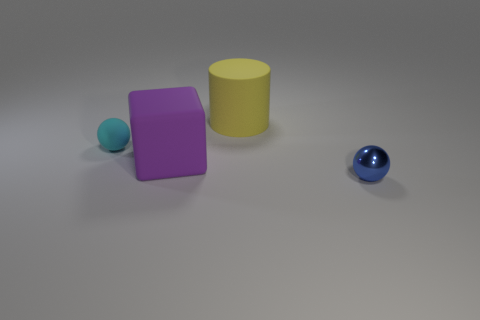Are there more objects that are behind the metallic thing than large yellow rubber cylinders that are to the right of the large rubber cylinder?
Provide a short and direct response. Yes. The tiny sphere that is on the left side of the yellow thing is what color?
Your answer should be very brief. Cyan. Is there a yellow rubber object of the same shape as the cyan thing?
Keep it short and to the point. No. What number of red objects are rubber cylinders or tiny matte balls?
Your answer should be compact. 0. Are there any other shiny cylinders of the same size as the yellow cylinder?
Your answer should be compact. No. How many brown shiny cylinders are there?
Make the answer very short. 0. What number of large objects are either blue objects or brown matte objects?
Offer a very short reply. 0. What is the color of the ball that is to the left of the ball that is in front of the small ball that is left of the blue ball?
Your answer should be very brief. Cyan. What number of other objects are the same color as the rubber sphere?
Ensure brevity in your answer.  0. How many rubber objects are either yellow cylinders or big red blocks?
Provide a short and direct response. 1. 